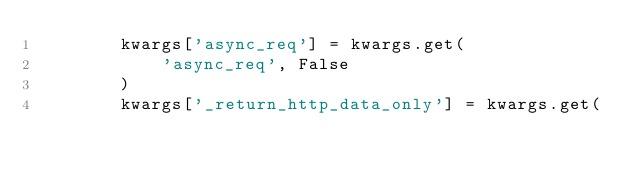Convert code to text. <code><loc_0><loc_0><loc_500><loc_500><_Python_>        kwargs['async_req'] = kwargs.get(
            'async_req', False
        )
        kwargs['_return_http_data_only'] = kwargs.get(</code> 